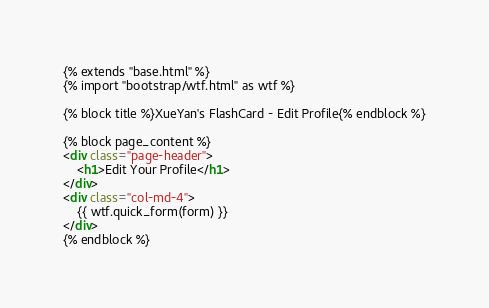Convert code to text. <code><loc_0><loc_0><loc_500><loc_500><_HTML_>{% extends "base.html" %}
{% import "bootstrap/wtf.html" as wtf %}

{% block title %}XueYan's FlashCard - Edit Profile{% endblock %}

{% block page_content %}
<div class="page-header">
    <h1>Edit Your Profile</h1>
</div>
<div class="col-md-4">
    {{ wtf.quick_form(form) }}
</div>
{% endblock %}
</code> 